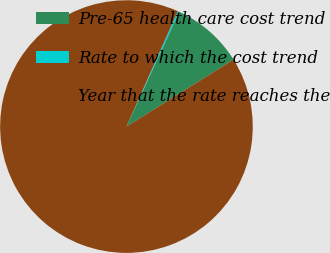<chart> <loc_0><loc_0><loc_500><loc_500><pie_chart><fcel>Pre-65 health care cost trend<fcel>Rate to which the cost trend<fcel>Year that the rate reaches the<nl><fcel>9.24%<fcel>0.2%<fcel>90.56%<nl></chart> 